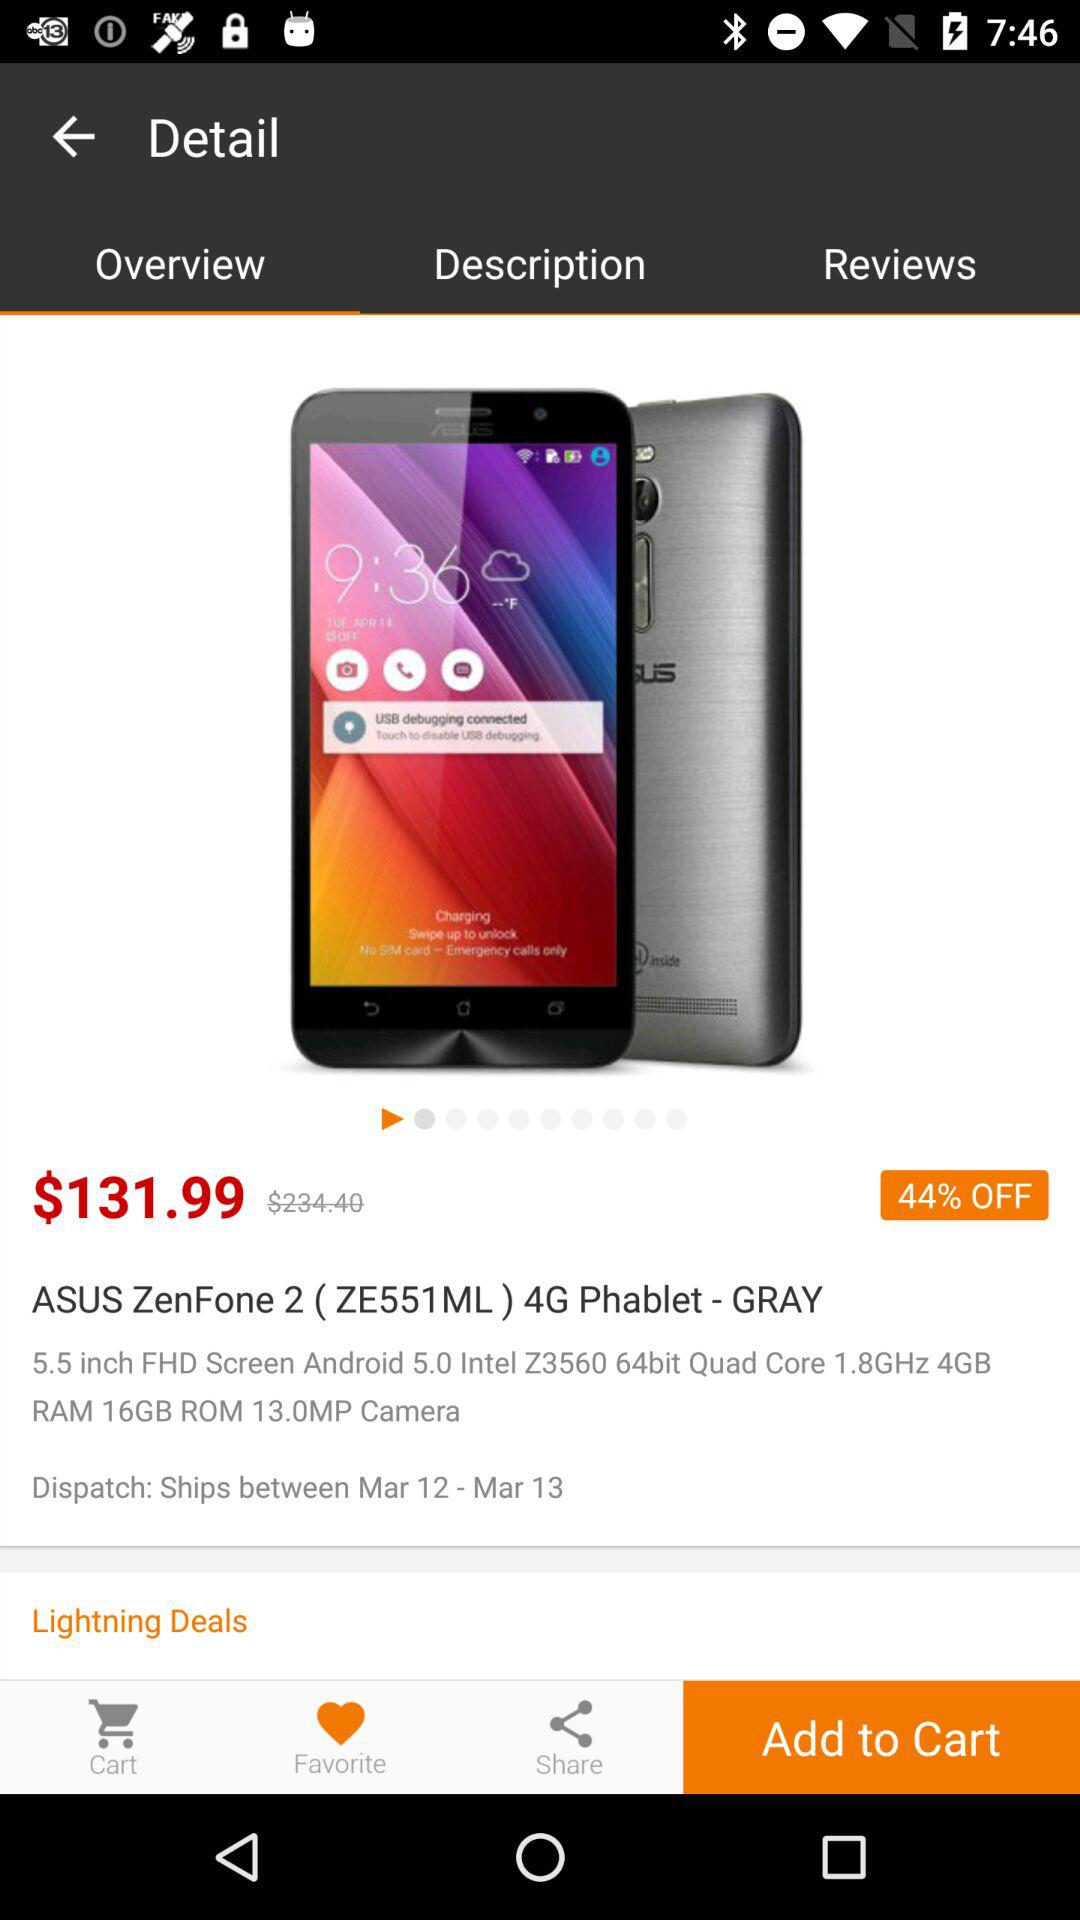What is the percentage off of the original price of the ASUS ZenFone 2 ( ZE551ML) 4G Phablet - GRAY?
Answer the question using a single word or phrase. 44% 